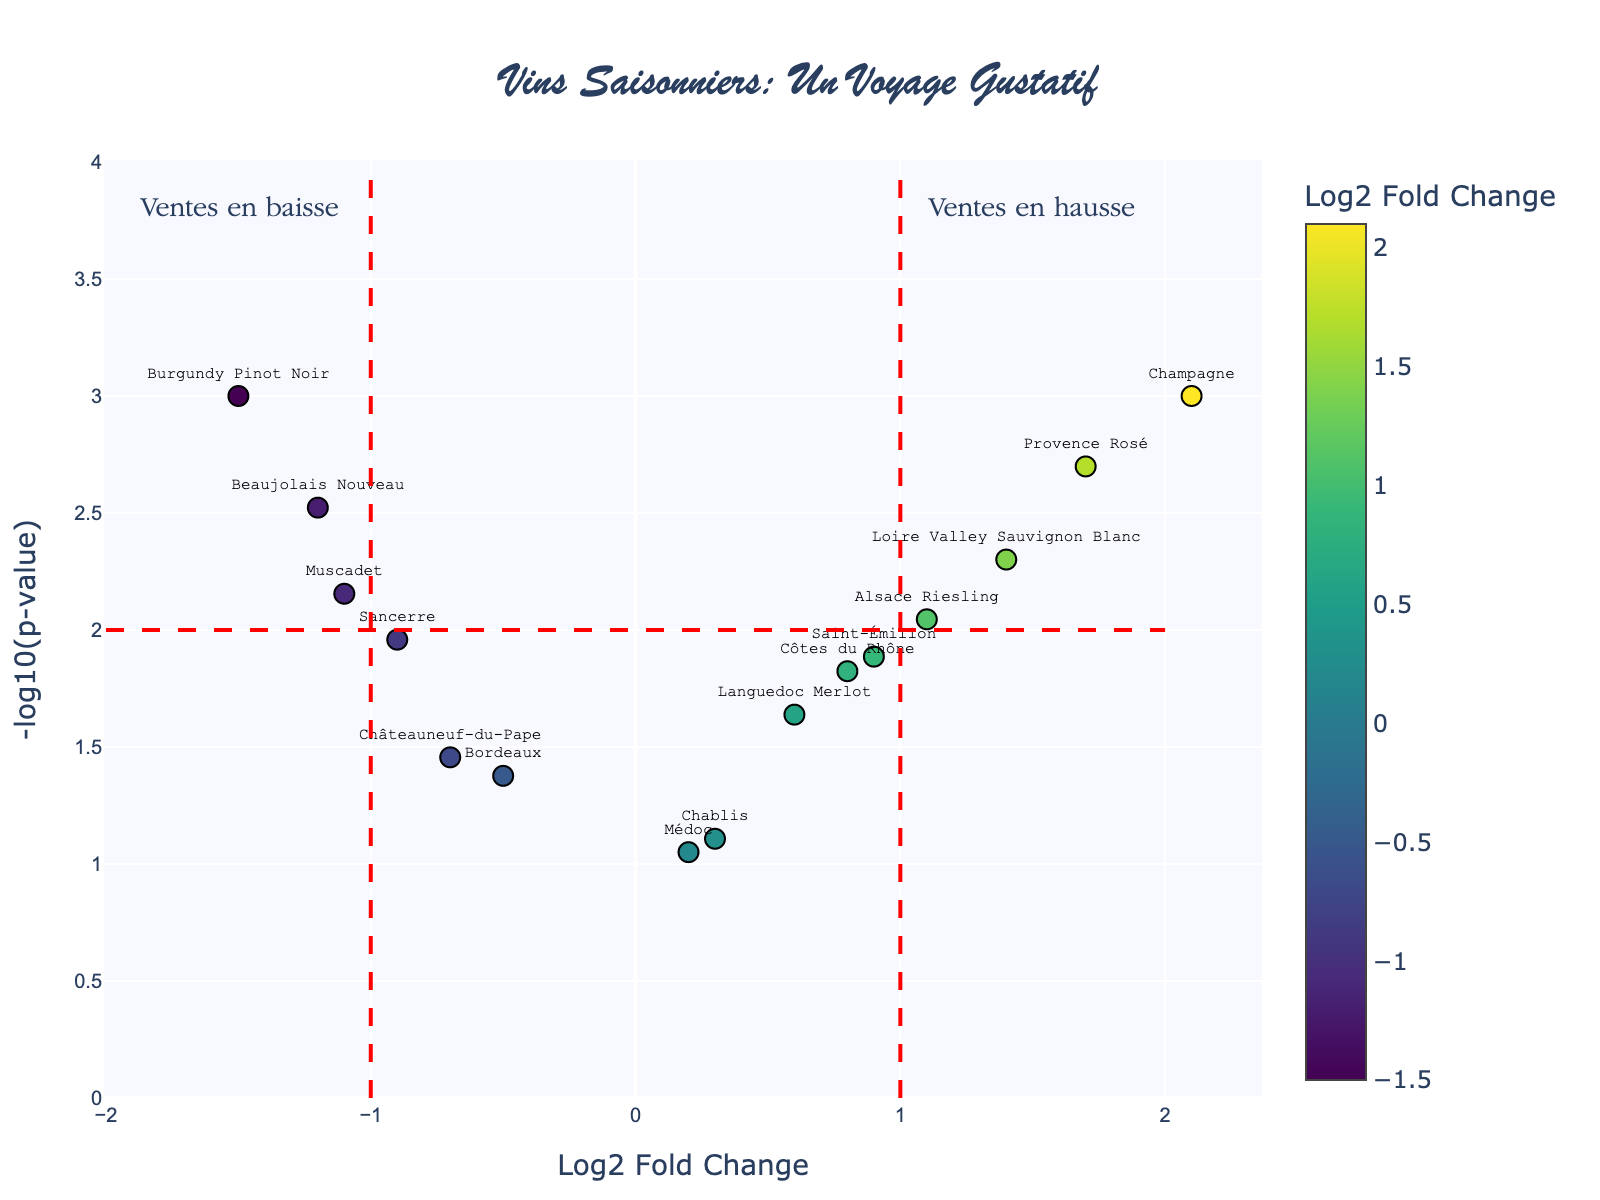What is the title of the figure? The title of the figure is usually displayed at the top of the plot. The title here is "Vins Saisonniers: Un Voyage Gustatif", which indicates that the figure is about seasonal wines.
Answer: Vins Saisonniers: Un Voyage Gustatif Which wine has the highest Log2 Fold Change? By observing the x-axis labeled "Log2 Fold Change" and noting the farthest point to the right, the wine with the highest Log2 Fold Change is Champagne.
Answer: Champagne How many wines have a Log2 Fold Change less than -1? Look left from the x-axis value of -1 and count the points that fall to the left of this line. The wines are Beaujolais Nouveau, Burgundy Pinot Noir, and Muscadet, totaling 3.
Answer: 3 What does the y-axis represent? The y-axis is labeled "-log10(p-value)", which typically represents the statistical significance of the data points, with higher values indicating more significant results.
Answer: -log10(p-value) Which wine has the most statistically significant trend based on the y-axis? The wine with the highest y-axis value (farthest up) is Champagne, reflecting the most statistically significant trend.
Answer: Champagne Compare the Log2 Fold Change between Beaujolais Nouveau and Provence Rosé. Which has a greater value? Beaujolais Nouveau has a Log2 Fold Change of -1.2, while Provence Rosé has a value of 1.7. Since 1.7 is greater than -1.2, Provence Rosé has the greater value.
Answer: Provence Rosé Which data points are marked by the red dashed lines on the x-axis? The red dashed lines mark Log2 Fold Change values of -1 and 1. We need to observe the points near these lines. Wines close to these values are Beaujolais Nouveau and Burgundy Pinot Noir for -1, and Languedoc Merlot and Côtes du Rhône for approximately 1.
Answer: Beaujolais Nouveau, Burgundy Pinot Noir, Languedoc Merlot, Côtes du Rhône Identify the wine with a Log2 Fold Change value of approximately 0.6. Locate the point near the 0.6 value on the x-axis and hover over it. The wine is Languedoc Merlot.
Answer: Languedoc Merlot Which wines fall into the region labeled "Ventes en baisse"? "Ventes en baisse" means decreasing sales and refers to wines with Log2 Fold Change values less than -1, indicated on the plot left of the red dashed line at -1. The wines are Beaujolais Nouveau, Burgundy Pinot Noir, and Muscadet.
Answer: Beaujolais Nouveau, Burgundy Pinot Noir, Muscadet 